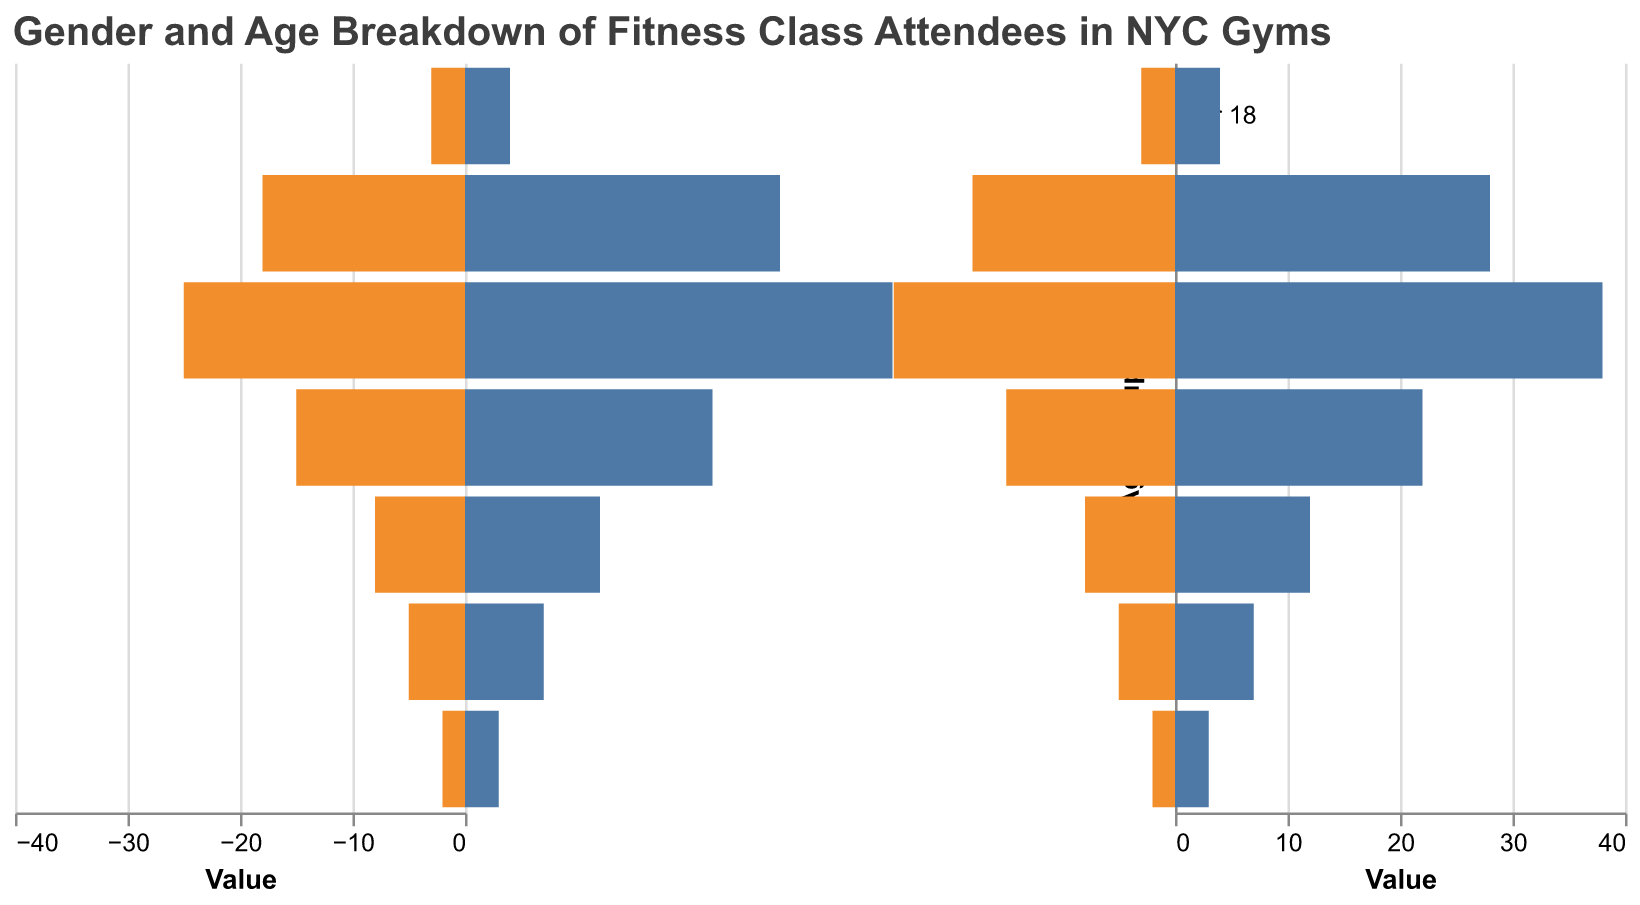What is the title of the figure? The title of the figure is located at the top of the plot in a large font size.
Answer: Gender and Age Breakdown of Fitness Class Attendees in NYC Gyms Which age group has the highest number of attendees? To find the age group with the highest number of attendees, add the Male and Female values for each age group. The group with the highest sum is the answer.
Answer: 25-34 How many female attendees are in the 35-44 age group? Locate the bar for the 35-44 age group in the Female section (right side of the plot). Read the value from the x-axis.
Answer: 22 What is the difference in the number of male attendees between the 18-24 and 25-34 age groups? Read the values of Male attendees for each age group (18 for 18-24 and 25 for 25-34). Subtract the number in the 18-24 group from the 25-34 group: 25 - 18.
Answer: 7 In which age group is the gender gap (difference between Male and Female attendees) the largest? Calculate the absolute difference between Male and Female for each age group:
Answer: 25-34 (Difference: 13) Which gender dominates the 45-54 age group? Compare the Male and Female values for the 45-54 age group. The gender with the higher value dominates.
Answer: Female Are there more female or male attendees in the gym overall? Sum up the total number of Female attendees and compare it with the sum of Male attendees. The group with the larger sum has more attendees.
Answer: Female What is the total number of attendees in the 'Under 18' age group? Add the Male and Female values for the 'Under 18' age group (3 Male, 4 Female). Sum = 3 + 4.
Answer: 7 Which age group has the smallest proportion of gym attendees? Identify the smallest sum of Male and Female values across all age groups.
Answer: 65+ How many more females than males are there in the 18-24 age group? Subtract the number of Male attendees from Female attendees in the 18-24 age group: 28 - 18.
Answer: 10 